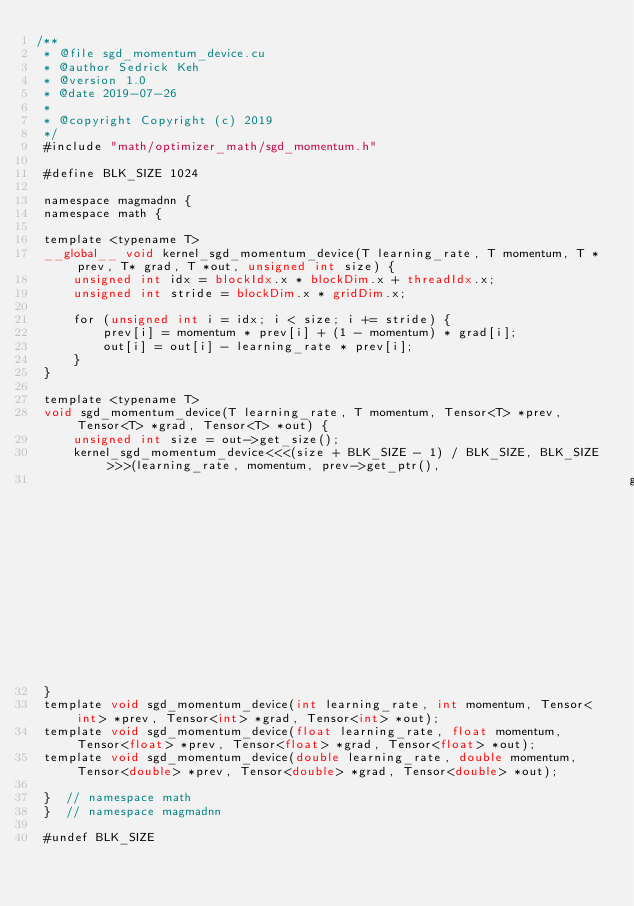<code> <loc_0><loc_0><loc_500><loc_500><_Cuda_>/**
 * @file sgd_momentum_device.cu
 * @author Sedrick Keh
 * @version 1.0
 * @date 2019-07-26
 *
 * @copyright Copyright (c) 2019
 */
 #include "math/optimizer_math/sgd_momentum.h"

 #define BLK_SIZE 1024
 
 namespace magmadnn {
 namespace math {
 
 template <typename T>
 __global__ void kernel_sgd_momentum_device(T learning_rate, T momentum, T *prev, T* grad, T *out, unsigned int size) {
     unsigned int idx = blockIdx.x * blockDim.x + threadIdx.x;
     unsigned int stride = blockDim.x * gridDim.x;
 
     for (unsigned int i = idx; i < size; i += stride) {
         prev[i] = momentum * prev[i] + (1 - momentum) * grad[i];
         out[i] = out[i] - learning_rate * prev[i];
     }
 }
 
 template <typename T>
 void sgd_momentum_device(T learning_rate, T momentum, Tensor<T> *prev, Tensor<T> *grad, Tensor<T> *out) {
     unsigned int size = out->get_size();
     kernel_sgd_momentum_device<<<(size + BLK_SIZE - 1) / BLK_SIZE, BLK_SIZE>>>(learning_rate, momentum, prev->get_ptr(), 
                                                                                grad->get_ptr(), out->get_ptr(), size);
 }
 template void sgd_momentum_device(int learning_rate, int momentum, Tensor<int> *prev, Tensor<int> *grad, Tensor<int> *out);
 template void sgd_momentum_device(float learning_rate, float momentum, Tensor<float> *prev, Tensor<float> *grad, Tensor<float> *out);
 template void sgd_momentum_device(double learning_rate, double momentum, Tensor<double> *prev, Tensor<double> *grad, Tensor<double> *out);
 
 }  // namespace math
 }  // namespace magmadnn
 
 #undef BLK_SIZE</code> 